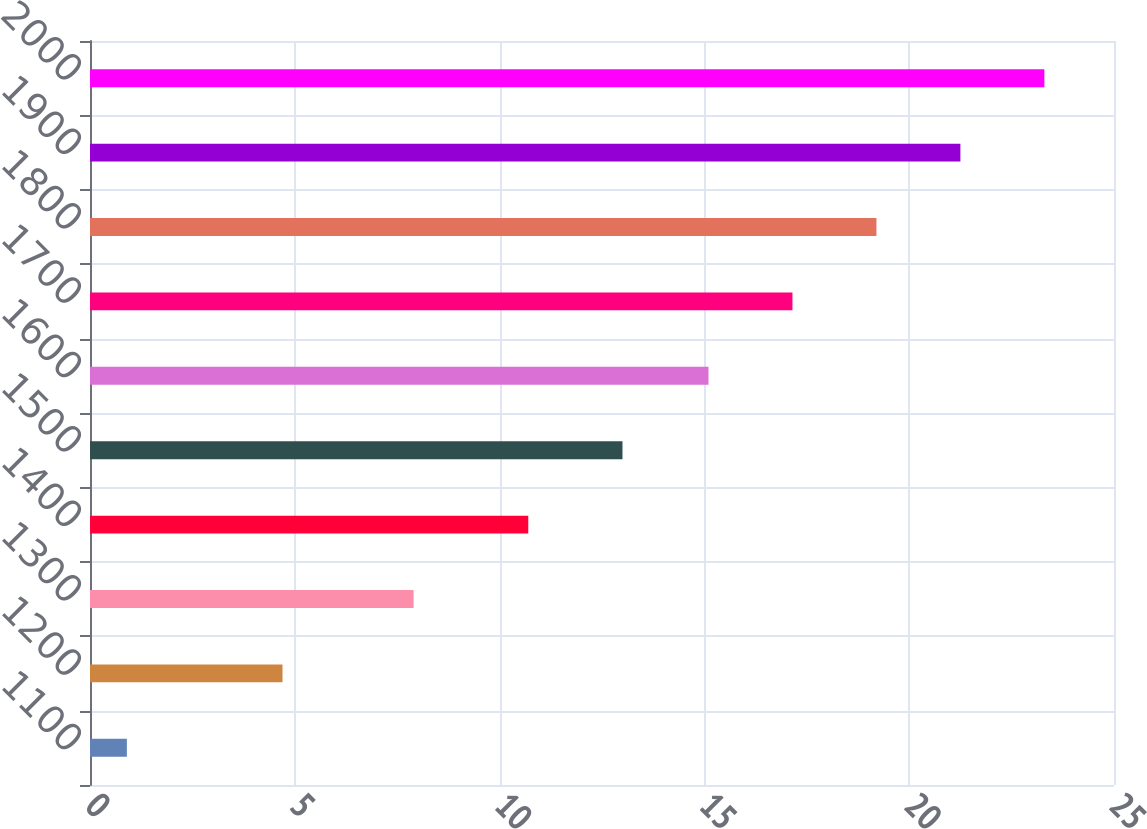Convert chart to OTSL. <chart><loc_0><loc_0><loc_500><loc_500><bar_chart><fcel>1100<fcel>1200<fcel>1300<fcel>1400<fcel>1500<fcel>1600<fcel>1700<fcel>1800<fcel>1900<fcel>2000<nl><fcel>0.9<fcel>4.7<fcel>7.9<fcel>10.7<fcel>13<fcel>15.1<fcel>17.15<fcel>19.2<fcel>21.25<fcel>23.3<nl></chart> 